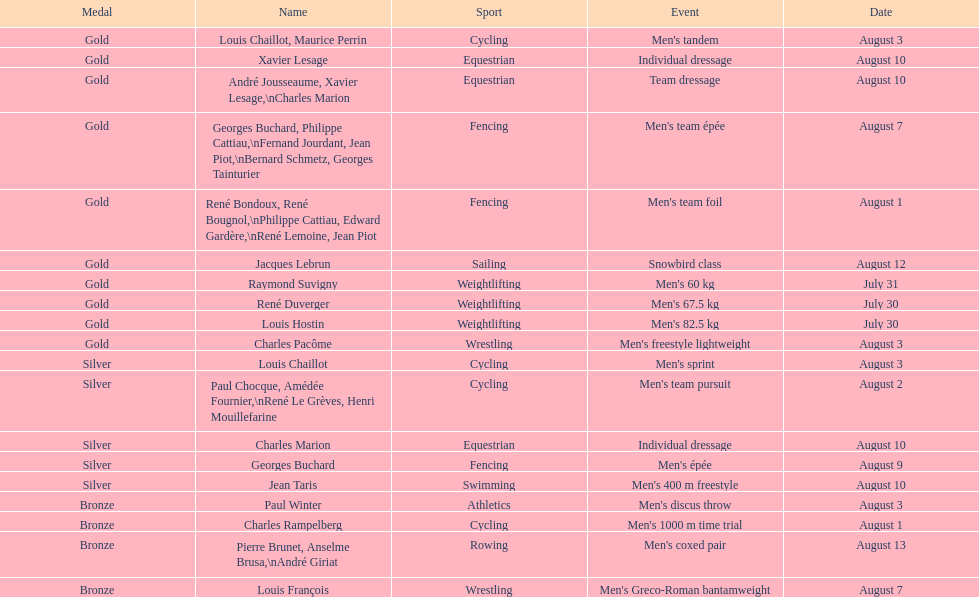In which sport did louis chalilot and paul chocque both win the same medal? Cycling. Can you parse all the data within this table? {'header': ['Medal', 'Name', 'Sport', 'Event', 'Date'], 'rows': [['Gold', 'Louis Chaillot, Maurice Perrin', 'Cycling', "Men's tandem", 'August 3'], ['Gold', 'Xavier Lesage', 'Equestrian', 'Individual dressage', 'August 10'], ['Gold', 'André Jousseaume, Xavier Lesage,\\nCharles Marion', 'Equestrian', 'Team dressage', 'August 10'], ['Gold', 'Georges Buchard, Philippe Cattiau,\\nFernand Jourdant, Jean Piot,\\nBernard Schmetz, Georges Tainturier', 'Fencing', "Men's team épée", 'August 7'], ['Gold', 'René Bondoux, René Bougnol,\\nPhilippe Cattiau, Edward Gardère,\\nRené Lemoine, Jean Piot', 'Fencing', "Men's team foil", 'August 1'], ['Gold', 'Jacques Lebrun', 'Sailing', 'Snowbird class', 'August 12'], ['Gold', 'Raymond Suvigny', 'Weightlifting', "Men's 60 kg", 'July 31'], ['Gold', 'René Duverger', 'Weightlifting', "Men's 67.5 kg", 'July 30'], ['Gold', 'Louis Hostin', 'Weightlifting', "Men's 82.5 kg", 'July 30'], ['Gold', 'Charles Pacôme', 'Wrestling', "Men's freestyle lightweight", 'August 3'], ['Silver', 'Louis Chaillot', 'Cycling', "Men's sprint", 'August 3'], ['Silver', 'Paul Chocque, Amédée Fournier,\\nRené Le Grèves, Henri Mouillefarine', 'Cycling', "Men's team pursuit", 'August 2'], ['Silver', 'Charles Marion', 'Equestrian', 'Individual dressage', 'August 10'], ['Silver', 'Georges Buchard', 'Fencing', "Men's épée", 'August 9'], ['Silver', 'Jean Taris', 'Swimming', "Men's 400 m freestyle", 'August 10'], ['Bronze', 'Paul Winter', 'Athletics', "Men's discus throw", 'August 3'], ['Bronze', 'Charles Rampelberg', 'Cycling', "Men's 1000 m time trial", 'August 1'], ['Bronze', 'Pierre Brunet, Anselme Brusa,\\nAndré Giriat', 'Rowing', "Men's coxed pair", 'August 13'], ['Bronze', 'Louis François', 'Wrestling', "Men's Greco-Roman bantamweight", 'August 7']]} 